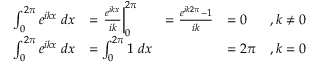<formula> <loc_0><loc_0><loc_500><loc_500>\begin{array} { r l r l r } { \int _ { 0 } ^ { 2 \pi } e ^ { i k x } \, d x } & { = \frac { e ^ { i k x } } { i k } \right | _ { 0 } ^ { 2 \pi } } & { = \frac { e ^ { i k 2 \pi } - 1 } { i k } } & { = 0 } & { , k \neq 0 } \\ { \int _ { 0 } ^ { 2 \pi } e ^ { i k x } \, d x } & { = \int _ { 0 } ^ { 2 \pi } 1 \, d x } & & { = 2 \pi } & { , k = 0 } \end{array}</formula> 